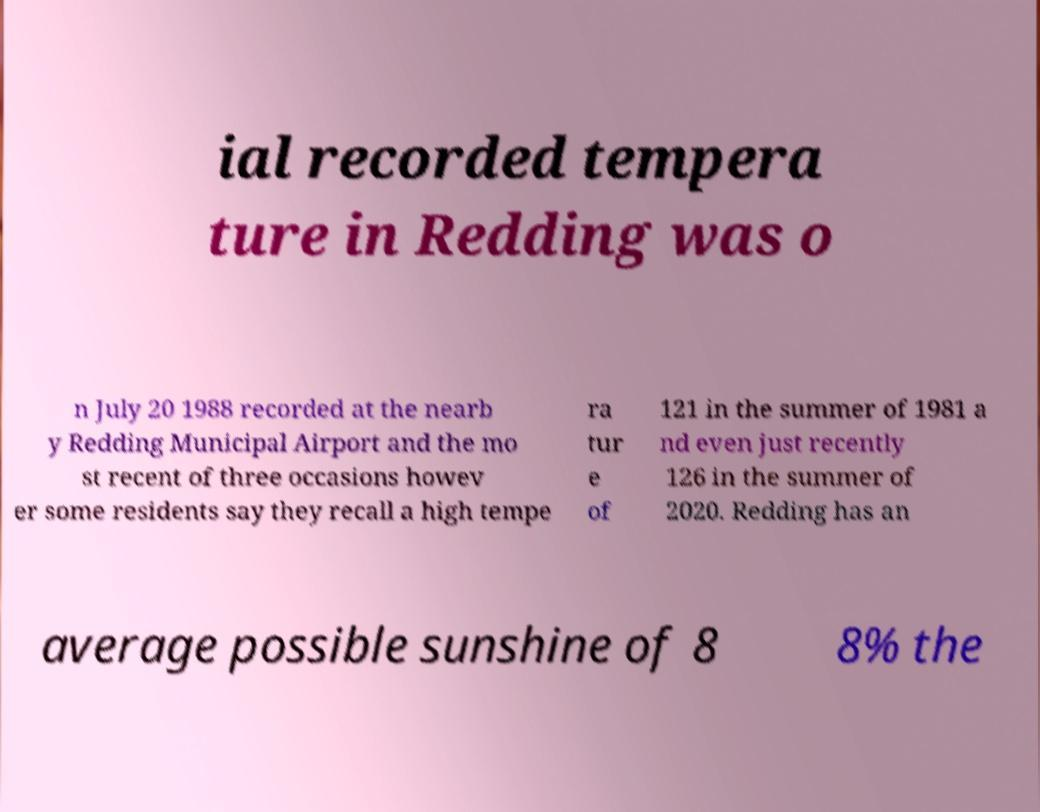Please identify and transcribe the text found in this image. ial recorded tempera ture in Redding was o n July 20 1988 recorded at the nearb y Redding Municipal Airport and the mo st recent of three occasions howev er some residents say they recall a high tempe ra tur e of 121 in the summer of 1981 a nd even just recently 126 in the summer of 2020. Redding has an average possible sunshine of 8 8% the 